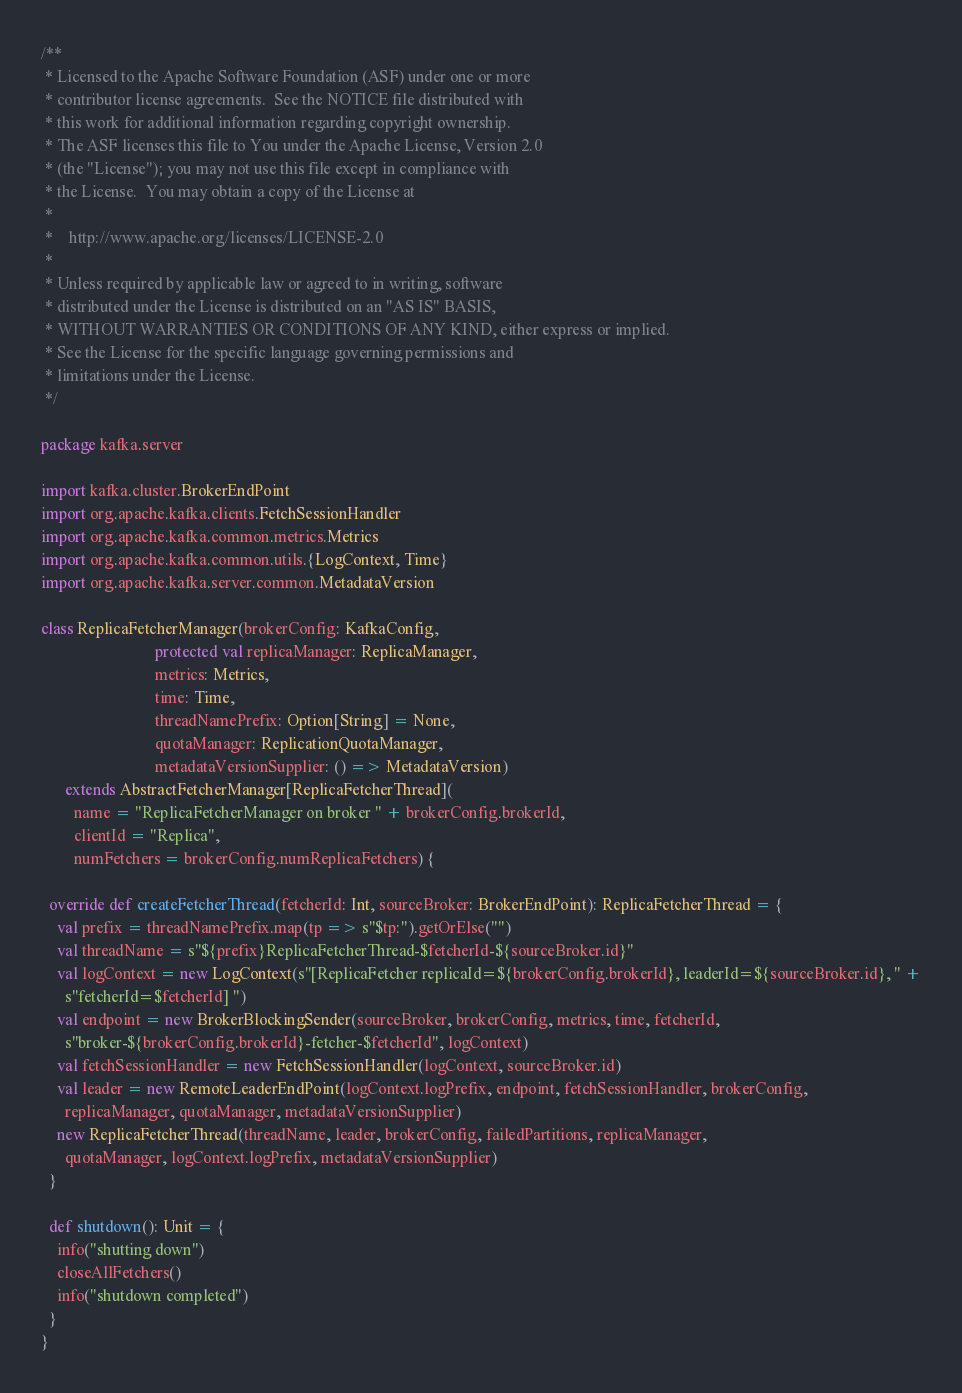<code> <loc_0><loc_0><loc_500><loc_500><_Scala_>/**
 * Licensed to the Apache Software Foundation (ASF) under one or more
 * contributor license agreements.  See the NOTICE file distributed with
 * this work for additional information regarding copyright ownership.
 * The ASF licenses this file to You under the Apache License, Version 2.0
 * (the "License"); you may not use this file except in compliance with
 * the License.  You may obtain a copy of the License at
 *
 *    http://www.apache.org/licenses/LICENSE-2.0
 *
 * Unless required by applicable law or agreed to in writing, software
 * distributed under the License is distributed on an "AS IS" BASIS,
 * WITHOUT WARRANTIES OR CONDITIONS OF ANY KIND, either express or implied.
 * See the License for the specific language governing permissions and
 * limitations under the License.
 */

package kafka.server

import kafka.cluster.BrokerEndPoint
import org.apache.kafka.clients.FetchSessionHandler
import org.apache.kafka.common.metrics.Metrics
import org.apache.kafka.common.utils.{LogContext, Time}
import org.apache.kafka.server.common.MetadataVersion

class ReplicaFetcherManager(brokerConfig: KafkaConfig,
                            protected val replicaManager: ReplicaManager,
                            metrics: Metrics,
                            time: Time,
                            threadNamePrefix: Option[String] = None,
                            quotaManager: ReplicationQuotaManager,
                            metadataVersionSupplier: () => MetadataVersion)
      extends AbstractFetcherManager[ReplicaFetcherThread](
        name = "ReplicaFetcherManager on broker " + brokerConfig.brokerId,
        clientId = "Replica",
        numFetchers = brokerConfig.numReplicaFetchers) {

  override def createFetcherThread(fetcherId: Int, sourceBroker: BrokerEndPoint): ReplicaFetcherThread = {
    val prefix = threadNamePrefix.map(tp => s"$tp:").getOrElse("")
    val threadName = s"${prefix}ReplicaFetcherThread-$fetcherId-${sourceBroker.id}"
    val logContext = new LogContext(s"[ReplicaFetcher replicaId=${brokerConfig.brokerId}, leaderId=${sourceBroker.id}, " +
      s"fetcherId=$fetcherId] ")
    val endpoint = new BrokerBlockingSender(sourceBroker, brokerConfig, metrics, time, fetcherId,
      s"broker-${brokerConfig.brokerId}-fetcher-$fetcherId", logContext)
    val fetchSessionHandler = new FetchSessionHandler(logContext, sourceBroker.id)
    val leader = new RemoteLeaderEndPoint(logContext.logPrefix, endpoint, fetchSessionHandler, brokerConfig,
      replicaManager, quotaManager, metadataVersionSupplier)
    new ReplicaFetcherThread(threadName, leader, brokerConfig, failedPartitions, replicaManager,
      quotaManager, logContext.logPrefix, metadataVersionSupplier)
  }

  def shutdown(): Unit = {
    info("shutting down")
    closeAllFetchers()
    info("shutdown completed")
  }
}
</code> 